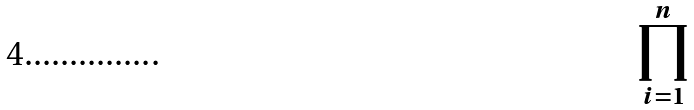Convert formula to latex. <formula><loc_0><loc_0><loc_500><loc_500>\prod _ { i = 1 } ^ { n }</formula> 